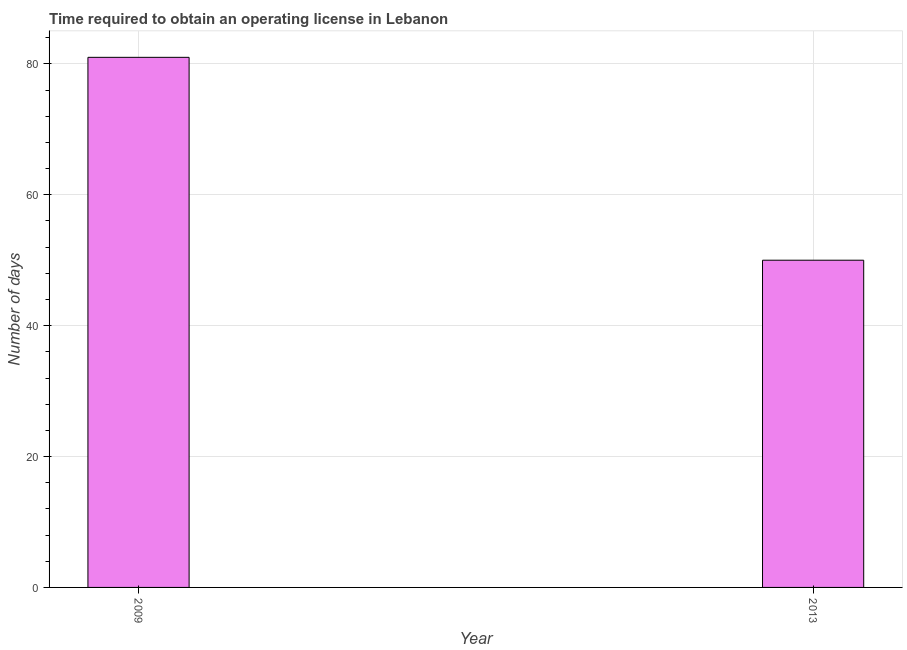Does the graph contain any zero values?
Keep it short and to the point. No. What is the title of the graph?
Provide a short and direct response. Time required to obtain an operating license in Lebanon. What is the label or title of the Y-axis?
Offer a terse response. Number of days. Across all years, what is the maximum number of days to obtain operating license?
Your answer should be compact. 81. Across all years, what is the minimum number of days to obtain operating license?
Provide a succinct answer. 50. In which year was the number of days to obtain operating license maximum?
Make the answer very short. 2009. In which year was the number of days to obtain operating license minimum?
Ensure brevity in your answer.  2013. What is the sum of the number of days to obtain operating license?
Offer a terse response. 131. What is the difference between the number of days to obtain operating license in 2009 and 2013?
Offer a very short reply. 31. What is the average number of days to obtain operating license per year?
Your response must be concise. 65. What is the median number of days to obtain operating license?
Offer a very short reply. 65.5. What is the ratio of the number of days to obtain operating license in 2009 to that in 2013?
Keep it short and to the point. 1.62. Is the number of days to obtain operating license in 2009 less than that in 2013?
Your answer should be compact. No. Are the values on the major ticks of Y-axis written in scientific E-notation?
Offer a terse response. No. What is the Number of days in 2013?
Ensure brevity in your answer.  50. What is the difference between the Number of days in 2009 and 2013?
Provide a succinct answer. 31. What is the ratio of the Number of days in 2009 to that in 2013?
Provide a short and direct response. 1.62. 